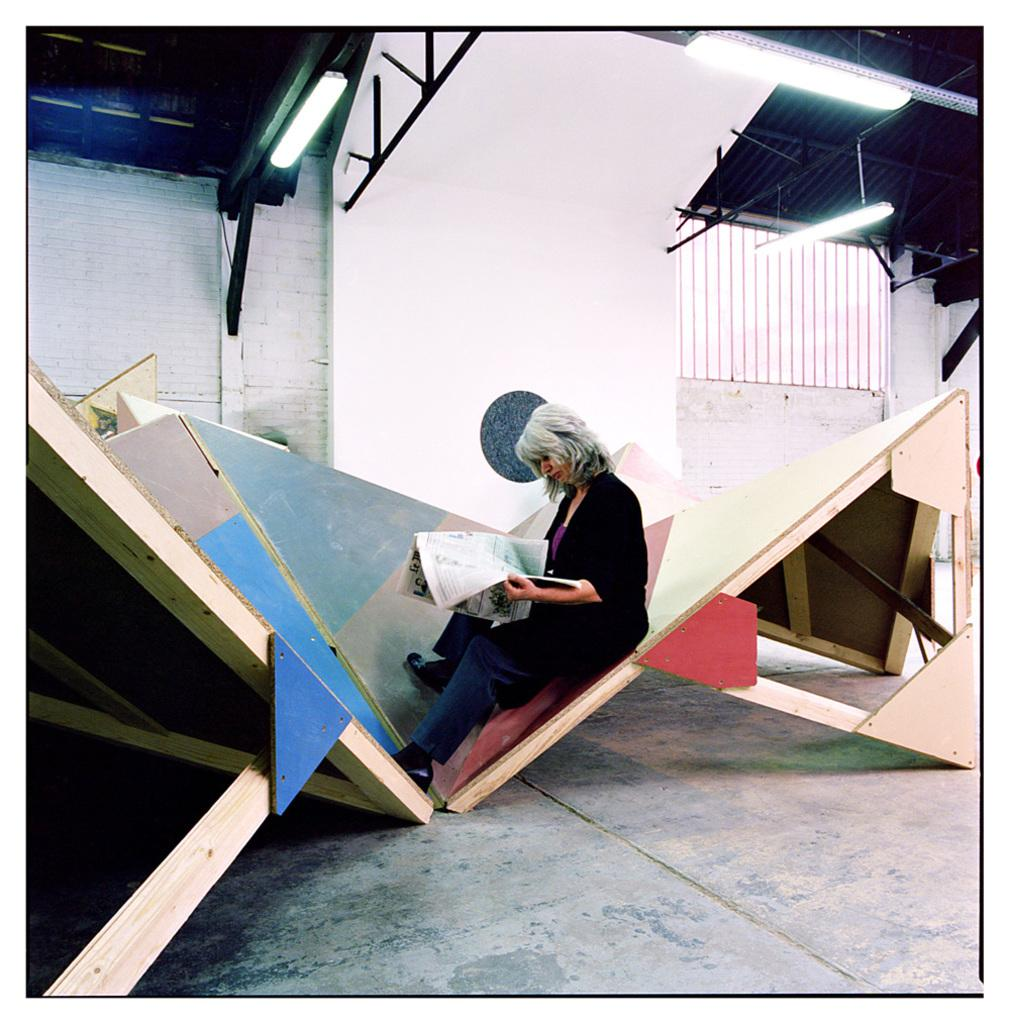What is the woman in the image doing? The woman is sitting in the image. What is the woman holding in the image? The woman is holding a newspaper. Can you describe the wooden object in the image? There is a wooden object in the image, but its specific details are not mentioned. What is visible above the woman in the image? There is a roof visible in the image, and tube lights are attached to the roof. Is there any source of natural light in the image? There is a window in the image, which could provide natural light. What type of book is the woman reading in the image? The woman is holding a newspaper, not a book, in the image. Can you see the woman's toes in the image? There is no mention of the woman's feet or toes in the image, so it cannot be determined if they are visible. 